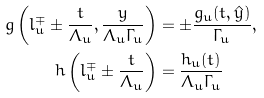<formula> <loc_0><loc_0><loc_500><loc_500>g \left ( l ^ { \mp } _ { u } \pm \frac { t } { \varLambda _ { u } } , \frac { y } { \varLambda _ { u } \varGamma _ { u } } \right ) & = \pm \frac { g _ { u } ( t , \hat { y } ) } { \varGamma _ { u } } , \\ h \left ( l ^ { \mp } _ { u } \pm \frac { t } { \varLambda _ { u } } \right ) & = \frac { h _ { u } ( t ) } { \varLambda _ { u } \varGamma _ { u } }</formula> 